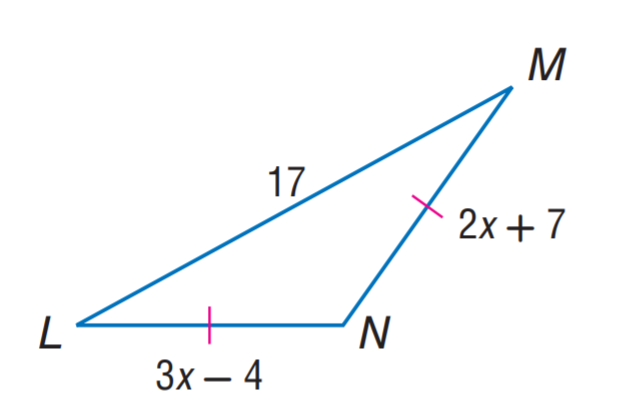Answer the mathemtical geometry problem and directly provide the correct option letter.
Question: Find M N.
Choices: A: 11 B: 15 C: 17 D: 29 D 